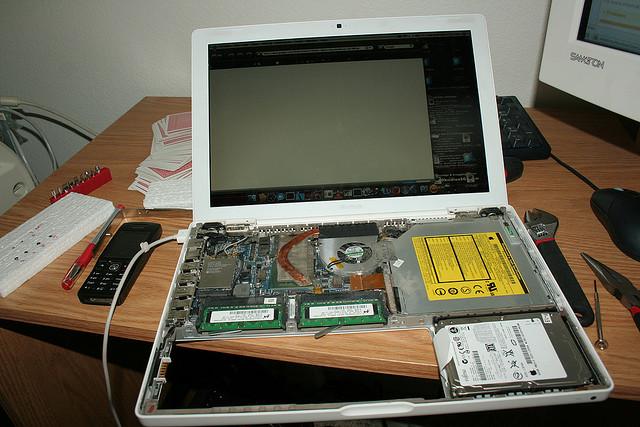Where are the memory slots located?
Keep it brief. Under keyboard. Has the warranty been voided?
Be succinct. Yes. Is the computer turned off?
Give a very brief answer. Yes. Is this laptop being repaired?
Keep it brief. Yes. 